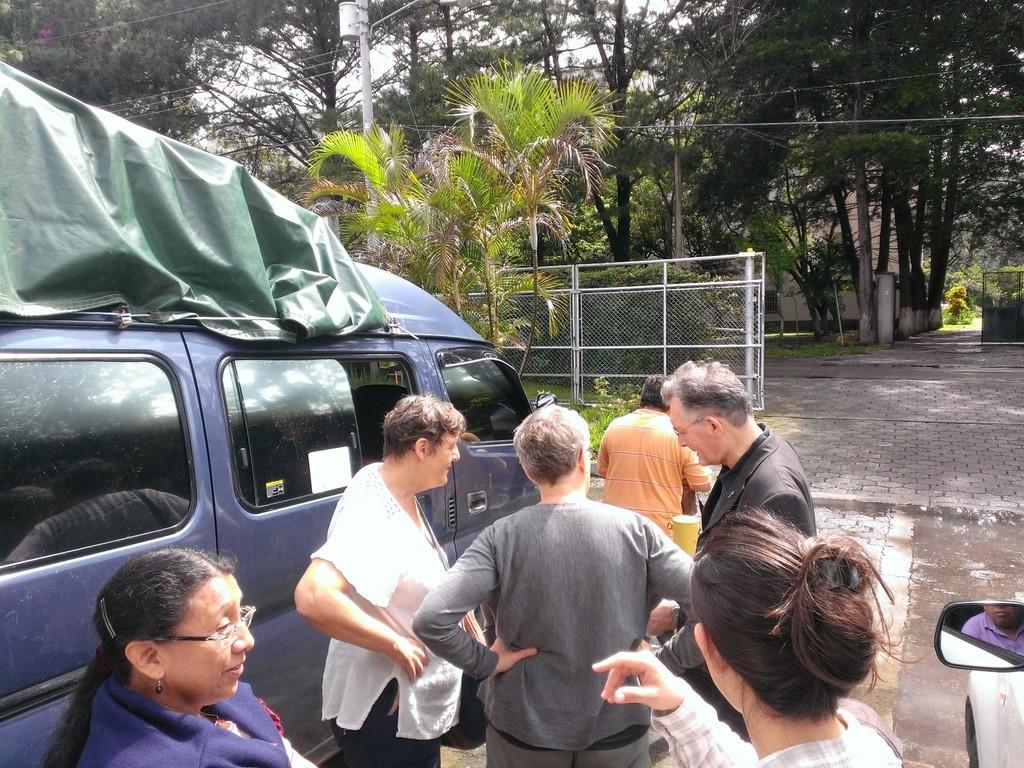Please provide a concise description of this image. On the left side of the image there is a vehicle, in front of the vehicle there are a few people standing. On the right side of the image there is another vehicle and we can see there is a person sitting in the vehicle from the side mirror of the vehicle. In the background there is a railing, trees and one utility pole. 